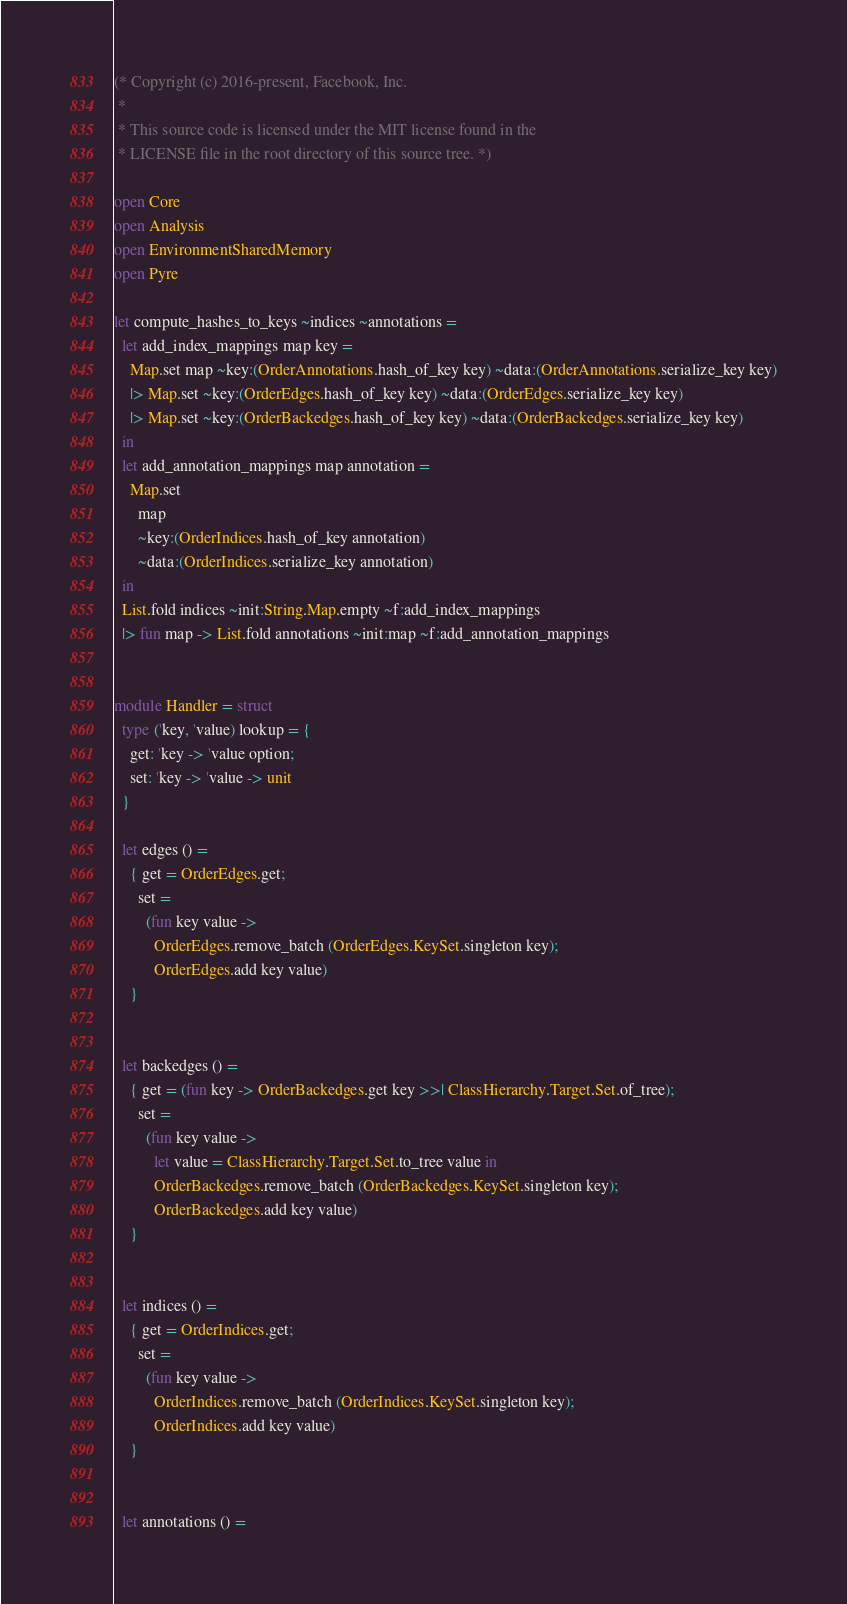<code> <loc_0><loc_0><loc_500><loc_500><_OCaml_>(* Copyright (c) 2016-present, Facebook, Inc.
 *
 * This source code is licensed under the MIT license found in the
 * LICENSE file in the root directory of this source tree. *)

open Core
open Analysis
open EnvironmentSharedMemory
open Pyre

let compute_hashes_to_keys ~indices ~annotations =
  let add_index_mappings map key =
    Map.set map ~key:(OrderAnnotations.hash_of_key key) ~data:(OrderAnnotations.serialize_key key)
    |> Map.set ~key:(OrderEdges.hash_of_key key) ~data:(OrderEdges.serialize_key key)
    |> Map.set ~key:(OrderBackedges.hash_of_key key) ~data:(OrderBackedges.serialize_key key)
  in
  let add_annotation_mappings map annotation =
    Map.set
      map
      ~key:(OrderIndices.hash_of_key annotation)
      ~data:(OrderIndices.serialize_key annotation)
  in
  List.fold indices ~init:String.Map.empty ~f:add_index_mappings
  |> fun map -> List.fold annotations ~init:map ~f:add_annotation_mappings


module Handler = struct
  type ('key, 'value) lookup = {
    get: 'key -> 'value option;
    set: 'key -> 'value -> unit
  }

  let edges () =
    { get = OrderEdges.get;
      set =
        (fun key value ->
          OrderEdges.remove_batch (OrderEdges.KeySet.singleton key);
          OrderEdges.add key value)
    }


  let backedges () =
    { get = (fun key -> OrderBackedges.get key >>| ClassHierarchy.Target.Set.of_tree);
      set =
        (fun key value ->
          let value = ClassHierarchy.Target.Set.to_tree value in
          OrderBackedges.remove_batch (OrderBackedges.KeySet.singleton key);
          OrderBackedges.add key value)
    }


  let indices () =
    { get = OrderIndices.get;
      set =
        (fun key value ->
          OrderIndices.remove_batch (OrderIndices.KeySet.singleton key);
          OrderIndices.add key value)
    }


  let annotations () =</code> 